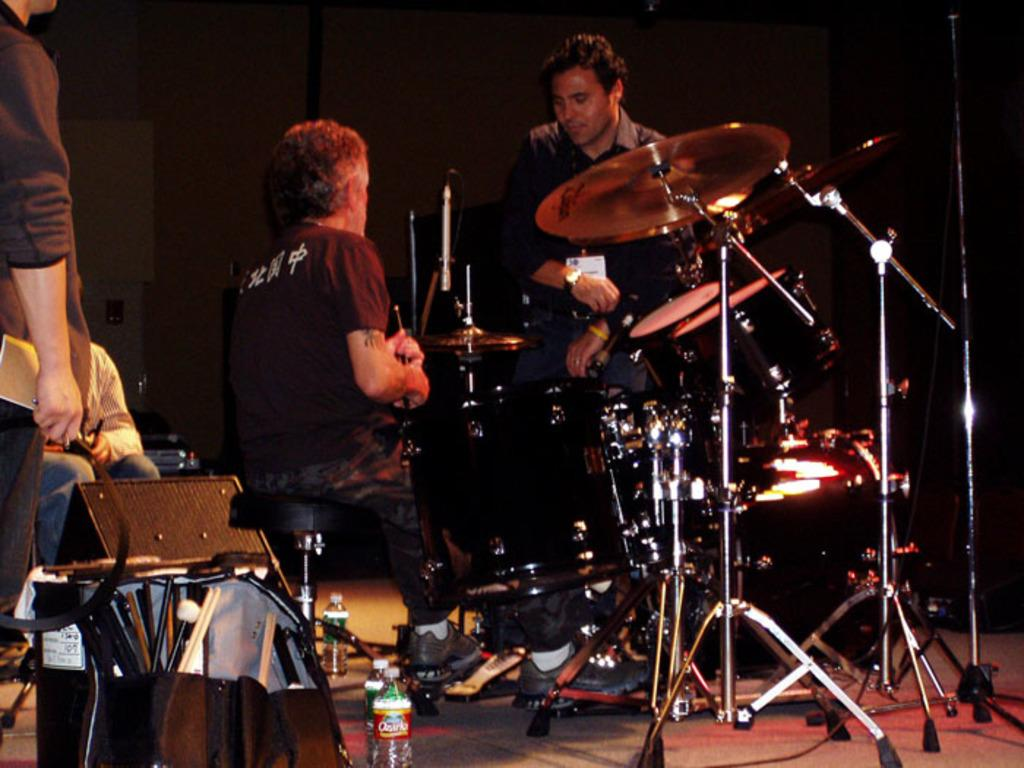How many people are in the image? There is a group of people in the image. What are the people doing in the image? Musical instruments are present in the image, suggesting that the people might be playing music. What else can be seen in the image besides the people and musical instruments? There are stands and bottles visible on the floor. What is visible in the background of the image? There is a wall in the background of the image. Can you describe the snake that is slithering across the floor in the image? There is no snake present in the image; only people, musical instruments, stands, and bottles are visible. 